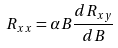<formula> <loc_0><loc_0><loc_500><loc_500>R _ { x x } = \alpha B \frac { d R _ { x y } } { d B }</formula> 